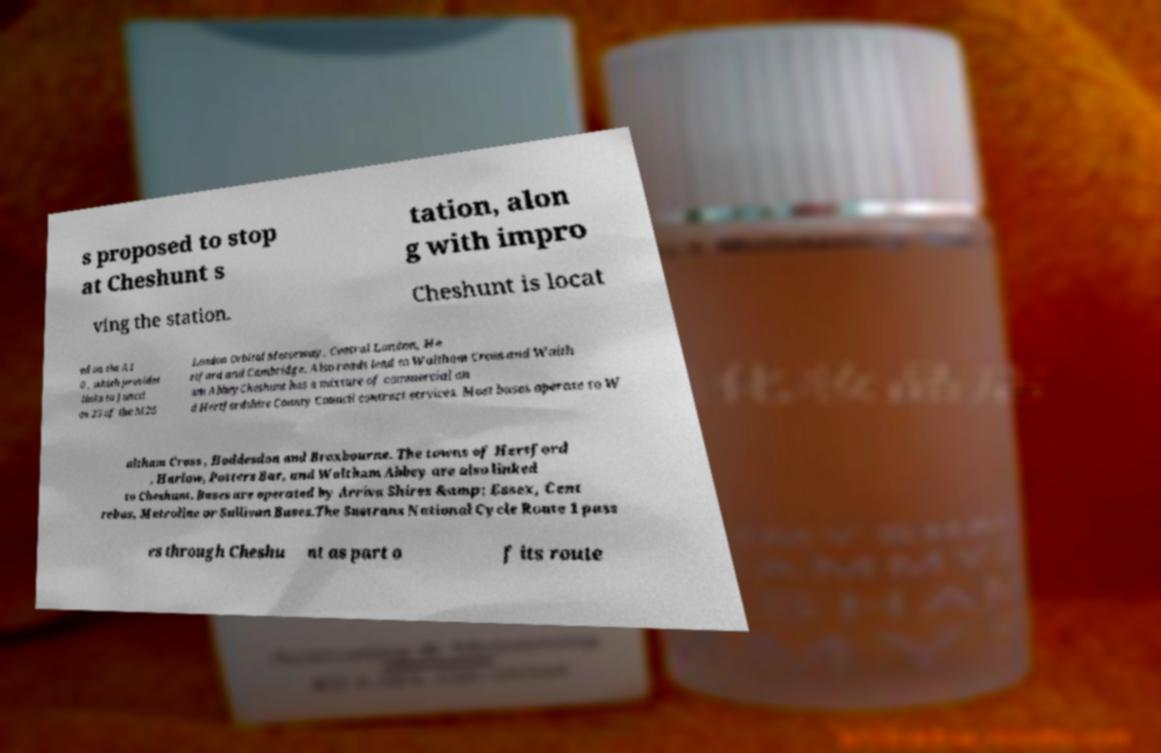For documentation purposes, I need the text within this image transcribed. Could you provide that? s proposed to stop at Cheshunt s tation, alon g with impro ving the station. Cheshunt is locat ed on the A1 0 , which provides links to Juncti on 25 of the M25 London Orbital Motorway, Central London, He rtford and Cambridge. Also roads lead to Waltham Cross and Walth am AbbeyCheshunt has a mixture of commercial an d Hertfordshire County Council contract services. Most buses operate to W altham Cross , Hoddesdon and Broxbourne. The towns of Hertford , Harlow, Potters Bar, and Waltham Abbey are also linked to Cheshunt. Buses are operated by Arriva Shires &amp; Essex, Cent rebus, Metroline or Sullivan Buses.The Sustrans National Cycle Route 1 pass es through Cheshu nt as part o f its route 